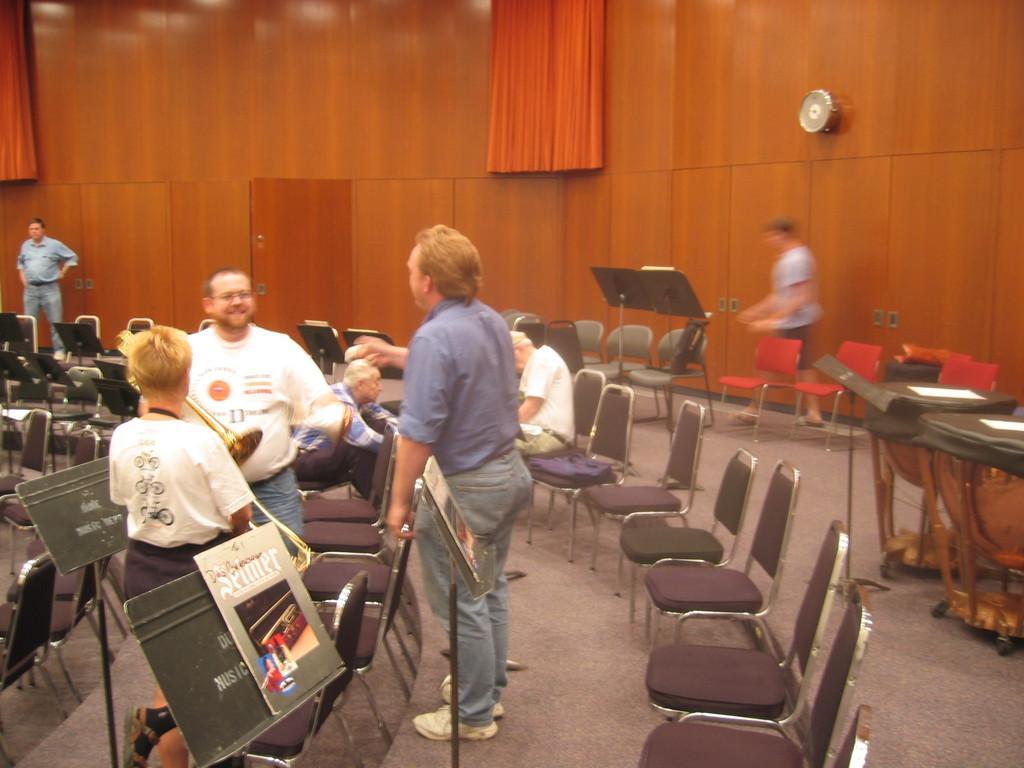In one or two sentences, can you explain what this image depicts? In this image there are group of people some of them are sitting and some of them are standing on the left side there are three persons who are standing and smiling and there are a group of chairs are there on the floor. On the top there is one wooden wall and curtains are there. In the middle there is one door on the right side there is one board and on the left side there are a group of boards are there. 